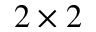<formula> <loc_0><loc_0><loc_500><loc_500>2 \times 2</formula> 